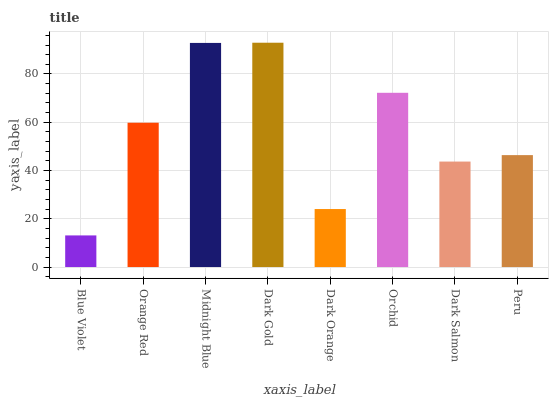Is Blue Violet the minimum?
Answer yes or no. Yes. Is Dark Gold the maximum?
Answer yes or no. Yes. Is Orange Red the minimum?
Answer yes or no. No. Is Orange Red the maximum?
Answer yes or no. No. Is Orange Red greater than Blue Violet?
Answer yes or no. Yes. Is Blue Violet less than Orange Red?
Answer yes or no. Yes. Is Blue Violet greater than Orange Red?
Answer yes or no. No. Is Orange Red less than Blue Violet?
Answer yes or no. No. Is Orange Red the high median?
Answer yes or no. Yes. Is Peru the low median?
Answer yes or no. Yes. Is Dark Orange the high median?
Answer yes or no. No. Is Dark Salmon the low median?
Answer yes or no. No. 